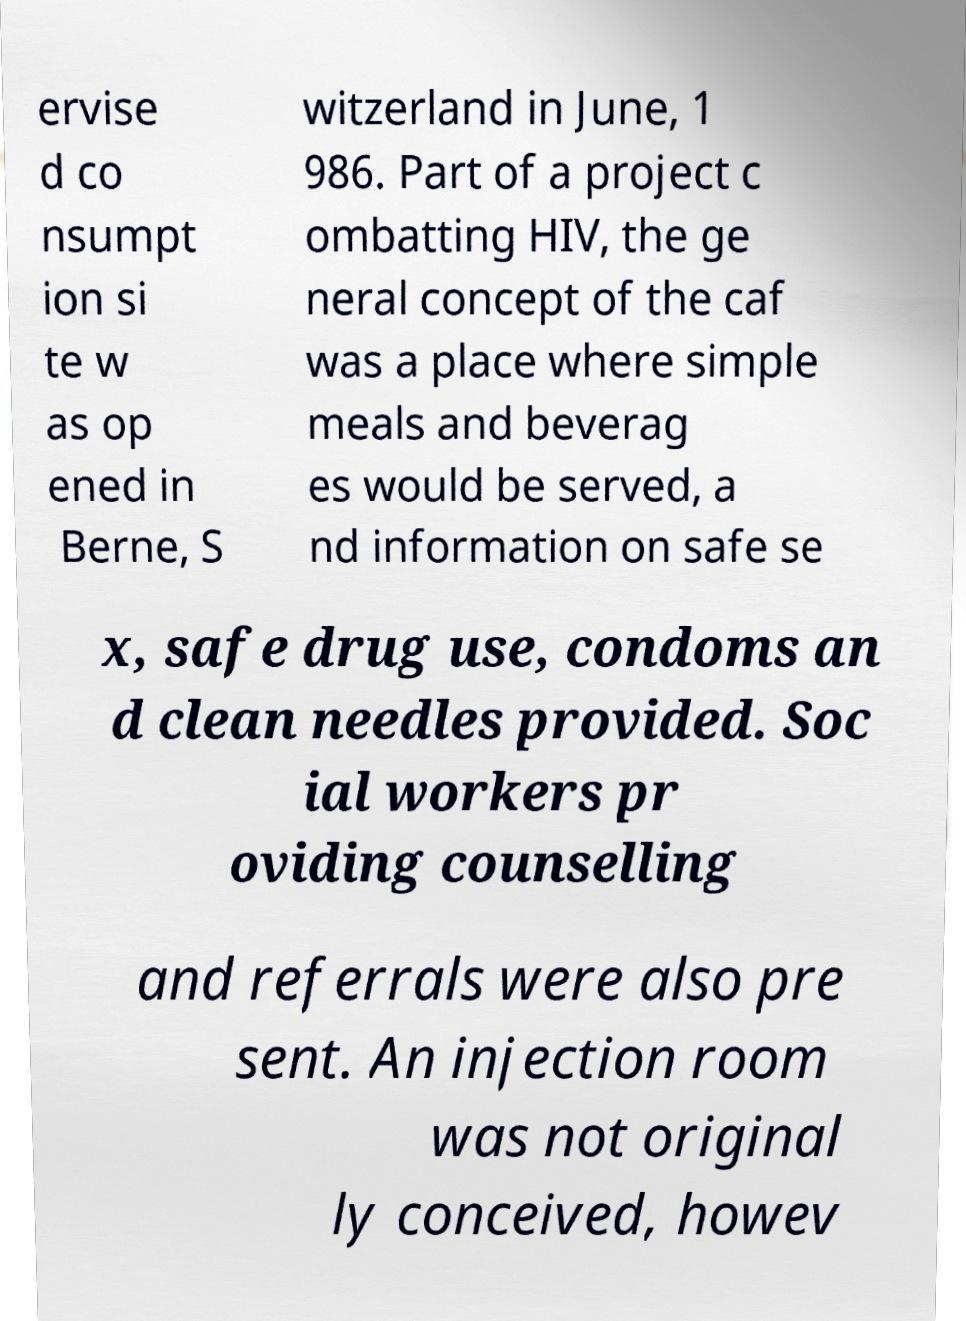Could you assist in decoding the text presented in this image and type it out clearly? ervise d co nsumpt ion si te w as op ened in Berne, S witzerland in June, 1 986. Part of a project c ombatting HIV, the ge neral concept of the caf was a place where simple meals and beverag es would be served, a nd information on safe se x, safe drug use, condoms an d clean needles provided. Soc ial workers pr oviding counselling and referrals were also pre sent. An injection room was not original ly conceived, howev 